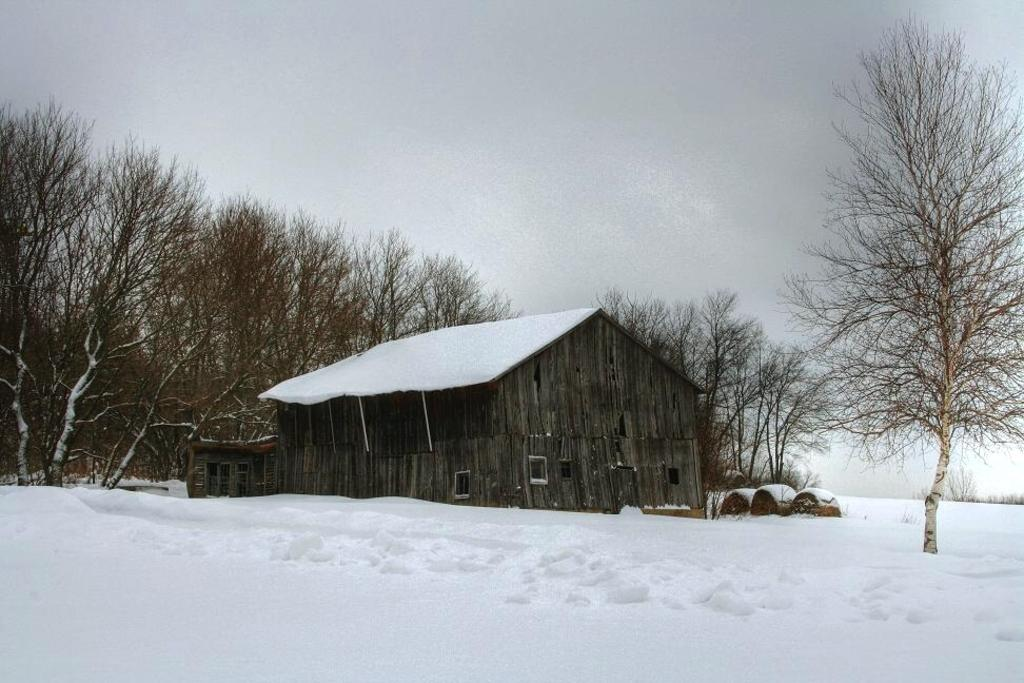What is the main subject of the image? The main subject of the image is a house. Can you describe the house in the image? The house has a wood wall and a roof. What else can be seen in the image besides the house? There are other objects in the image, and the background includes sky, clouds, trees, and snow. What type of voice can be heard coming from the house in the image? There is no voice present in the image, as it is a still picture of a house. What type of education is being provided in the image? There is no indication of any educational activity in the image, as it features a house and its surroundings. 